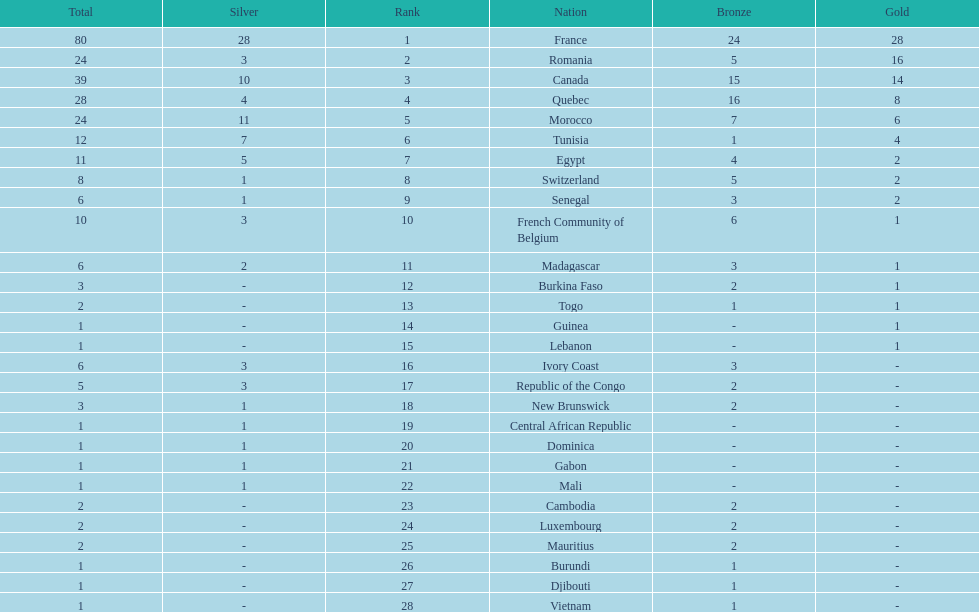How many nations won at least 10 medals? 8. 